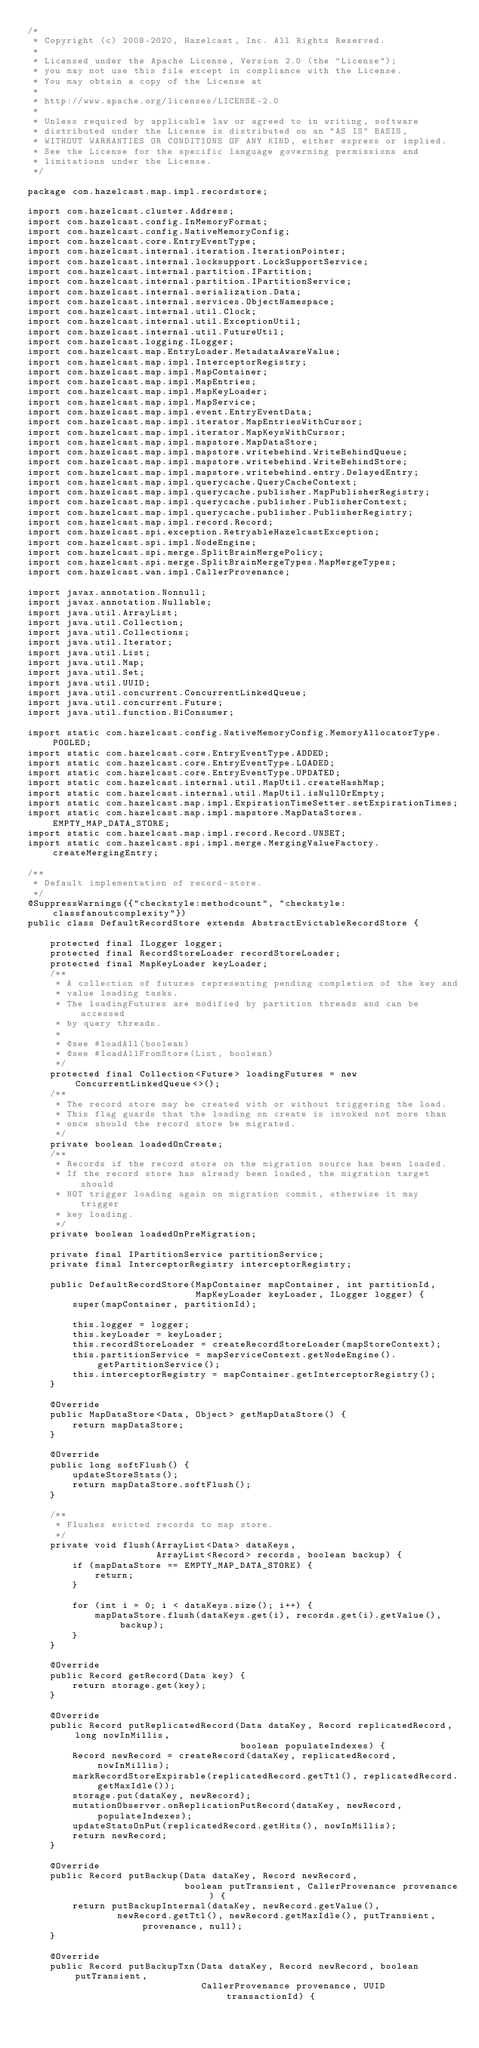<code> <loc_0><loc_0><loc_500><loc_500><_Java_>/*
 * Copyright (c) 2008-2020, Hazelcast, Inc. All Rights Reserved.
 *
 * Licensed under the Apache License, Version 2.0 (the "License");
 * you may not use this file except in compliance with the License.
 * You may obtain a copy of the License at
 *
 * http://www.apache.org/licenses/LICENSE-2.0
 *
 * Unless required by applicable law or agreed to in writing, software
 * distributed under the License is distributed on an "AS IS" BASIS,
 * WITHOUT WARRANTIES OR CONDITIONS OF ANY KIND, either express or implied.
 * See the License for the specific language governing permissions and
 * limitations under the License.
 */

package com.hazelcast.map.impl.recordstore;

import com.hazelcast.cluster.Address;
import com.hazelcast.config.InMemoryFormat;
import com.hazelcast.config.NativeMemoryConfig;
import com.hazelcast.core.EntryEventType;
import com.hazelcast.internal.iteration.IterationPointer;
import com.hazelcast.internal.locksupport.LockSupportService;
import com.hazelcast.internal.partition.IPartition;
import com.hazelcast.internal.partition.IPartitionService;
import com.hazelcast.internal.serialization.Data;
import com.hazelcast.internal.services.ObjectNamespace;
import com.hazelcast.internal.util.Clock;
import com.hazelcast.internal.util.ExceptionUtil;
import com.hazelcast.internal.util.FutureUtil;
import com.hazelcast.logging.ILogger;
import com.hazelcast.map.EntryLoader.MetadataAwareValue;
import com.hazelcast.map.impl.InterceptorRegistry;
import com.hazelcast.map.impl.MapContainer;
import com.hazelcast.map.impl.MapEntries;
import com.hazelcast.map.impl.MapKeyLoader;
import com.hazelcast.map.impl.MapService;
import com.hazelcast.map.impl.event.EntryEventData;
import com.hazelcast.map.impl.iterator.MapEntriesWithCursor;
import com.hazelcast.map.impl.iterator.MapKeysWithCursor;
import com.hazelcast.map.impl.mapstore.MapDataStore;
import com.hazelcast.map.impl.mapstore.writebehind.WriteBehindQueue;
import com.hazelcast.map.impl.mapstore.writebehind.WriteBehindStore;
import com.hazelcast.map.impl.mapstore.writebehind.entry.DelayedEntry;
import com.hazelcast.map.impl.querycache.QueryCacheContext;
import com.hazelcast.map.impl.querycache.publisher.MapPublisherRegistry;
import com.hazelcast.map.impl.querycache.publisher.PublisherContext;
import com.hazelcast.map.impl.querycache.publisher.PublisherRegistry;
import com.hazelcast.map.impl.record.Record;
import com.hazelcast.spi.exception.RetryableHazelcastException;
import com.hazelcast.spi.impl.NodeEngine;
import com.hazelcast.spi.merge.SplitBrainMergePolicy;
import com.hazelcast.spi.merge.SplitBrainMergeTypes.MapMergeTypes;
import com.hazelcast.wan.impl.CallerProvenance;

import javax.annotation.Nonnull;
import javax.annotation.Nullable;
import java.util.ArrayList;
import java.util.Collection;
import java.util.Collections;
import java.util.Iterator;
import java.util.List;
import java.util.Map;
import java.util.Set;
import java.util.UUID;
import java.util.concurrent.ConcurrentLinkedQueue;
import java.util.concurrent.Future;
import java.util.function.BiConsumer;

import static com.hazelcast.config.NativeMemoryConfig.MemoryAllocatorType.POOLED;
import static com.hazelcast.core.EntryEventType.ADDED;
import static com.hazelcast.core.EntryEventType.LOADED;
import static com.hazelcast.core.EntryEventType.UPDATED;
import static com.hazelcast.internal.util.MapUtil.createHashMap;
import static com.hazelcast.internal.util.MapUtil.isNullOrEmpty;
import static com.hazelcast.map.impl.ExpirationTimeSetter.setExpirationTimes;
import static com.hazelcast.map.impl.mapstore.MapDataStores.EMPTY_MAP_DATA_STORE;
import static com.hazelcast.map.impl.record.Record.UNSET;
import static com.hazelcast.spi.impl.merge.MergingValueFactory.createMergingEntry;

/**
 * Default implementation of record-store.
 */
@SuppressWarnings({"checkstyle:methodcount", "checkstyle:classfanoutcomplexity"})
public class DefaultRecordStore extends AbstractEvictableRecordStore {

    protected final ILogger logger;
    protected final RecordStoreLoader recordStoreLoader;
    protected final MapKeyLoader keyLoader;
    /**
     * A collection of futures representing pending completion of the key and
     * value loading tasks.
     * The loadingFutures are modified by partition threads and can be accessed
     * by query threads.
     *
     * @see #loadAll(boolean)
     * @see #loadAllFromStore(List, boolean)
     */
    protected final Collection<Future> loadingFutures = new ConcurrentLinkedQueue<>();
    /**
     * The record store may be created with or without triggering the load.
     * This flag guards that the loading on create is invoked not more than
     * once should the record store be migrated.
     */
    private boolean loadedOnCreate;
    /**
     * Records if the record store on the migration source has been loaded.
     * If the record store has already been loaded, the migration target should
     * NOT trigger loading again on migration commit, otherwise it may trigger
     * key loading.
     */
    private boolean loadedOnPreMigration;

    private final IPartitionService partitionService;
    private final InterceptorRegistry interceptorRegistry;

    public DefaultRecordStore(MapContainer mapContainer, int partitionId,
                              MapKeyLoader keyLoader, ILogger logger) {
        super(mapContainer, partitionId);

        this.logger = logger;
        this.keyLoader = keyLoader;
        this.recordStoreLoader = createRecordStoreLoader(mapStoreContext);
        this.partitionService = mapServiceContext.getNodeEngine().getPartitionService();
        this.interceptorRegistry = mapContainer.getInterceptorRegistry();
    }

    @Override
    public MapDataStore<Data, Object> getMapDataStore() {
        return mapDataStore;
    }

    @Override
    public long softFlush() {
        updateStoreStats();
        return mapDataStore.softFlush();
    }

    /**
     * Flushes evicted records to map store.
     */
    private void flush(ArrayList<Data> dataKeys,
                       ArrayList<Record> records, boolean backup) {
        if (mapDataStore == EMPTY_MAP_DATA_STORE) {
            return;
        }

        for (int i = 0; i < dataKeys.size(); i++) {
            mapDataStore.flush(dataKeys.get(i), records.get(i).getValue(), backup);
        }
    }

    @Override
    public Record getRecord(Data key) {
        return storage.get(key);
    }

    @Override
    public Record putReplicatedRecord(Data dataKey, Record replicatedRecord, long nowInMillis,
                                      boolean populateIndexes) {
        Record newRecord = createRecord(dataKey, replicatedRecord, nowInMillis);
        markRecordStoreExpirable(replicatedRecord.getTtl(), replicatedRecord.getMaxIdle());
        storage.put(dataKey, newRecord);
        mutationObserver.onReplicationPutRecord(dataKey, newRecord, populateIndexes);
        updateStatsOnPut(replicatedRecord.getHits(), nowInMillis);
        return newRecord;
    }

    @Override
    public Record putBackup(Data dataKey, Record newRecord,
                            boolean putTransient, CallerProvenance provenance) {
        return putBackupInternal(dataKey, newRecord.getValue(),
                newRecord.getTtl(), newRecord.getMaxIdle(), putTransient, provenance, null);
    }

    @Override
    public Record putBackupTxn(Data dataKey, Record newRecord, boolean putTransient,
                               CallerProvenance provenance, UUID transactionId) {</code> 